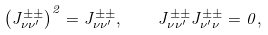Convert formula to latex. <formula><loc_0><loc_0><loc_500><loc_500>\left ( J _ { \nu \nu ^ { \prime } } ^ { \pm \pm } \right ) ^ { 2 } = J _ { \nu \nu ^ { \prime } } ^ { \pm \pm } , \quad J _ { \nu \nu ^ { \prime } } ^ { \pm \pm } J _ { \nu ^ { \prime } \nu } ^ { \pm \pm } = 0 ,</formula> 